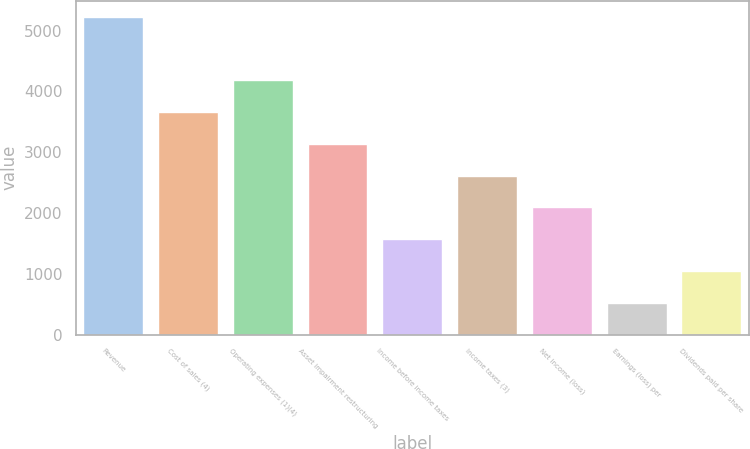<chart> <loc_0><loc_0><loc_500><loc_500><bar_chart><fcel>Revenue<fcel>Cost of sales (4)<fcel>Operating expenses (1)(4)<fcel>Asset impairment restructuring<fcel>Income before income taxes<fcel>Income taxes (3)<fcel>Net income (loss)<fcel>Earnings (loss) per<fcel>Dividends paid per share<nl><fcel>5228.3<fcel>3659.84<fcel>4182.66<fcel>3137.02<fcel>1568.56<fcel>2614.2<fcel>2091.38<fcel>522.92<fcel>1045.74<nl></chart> 